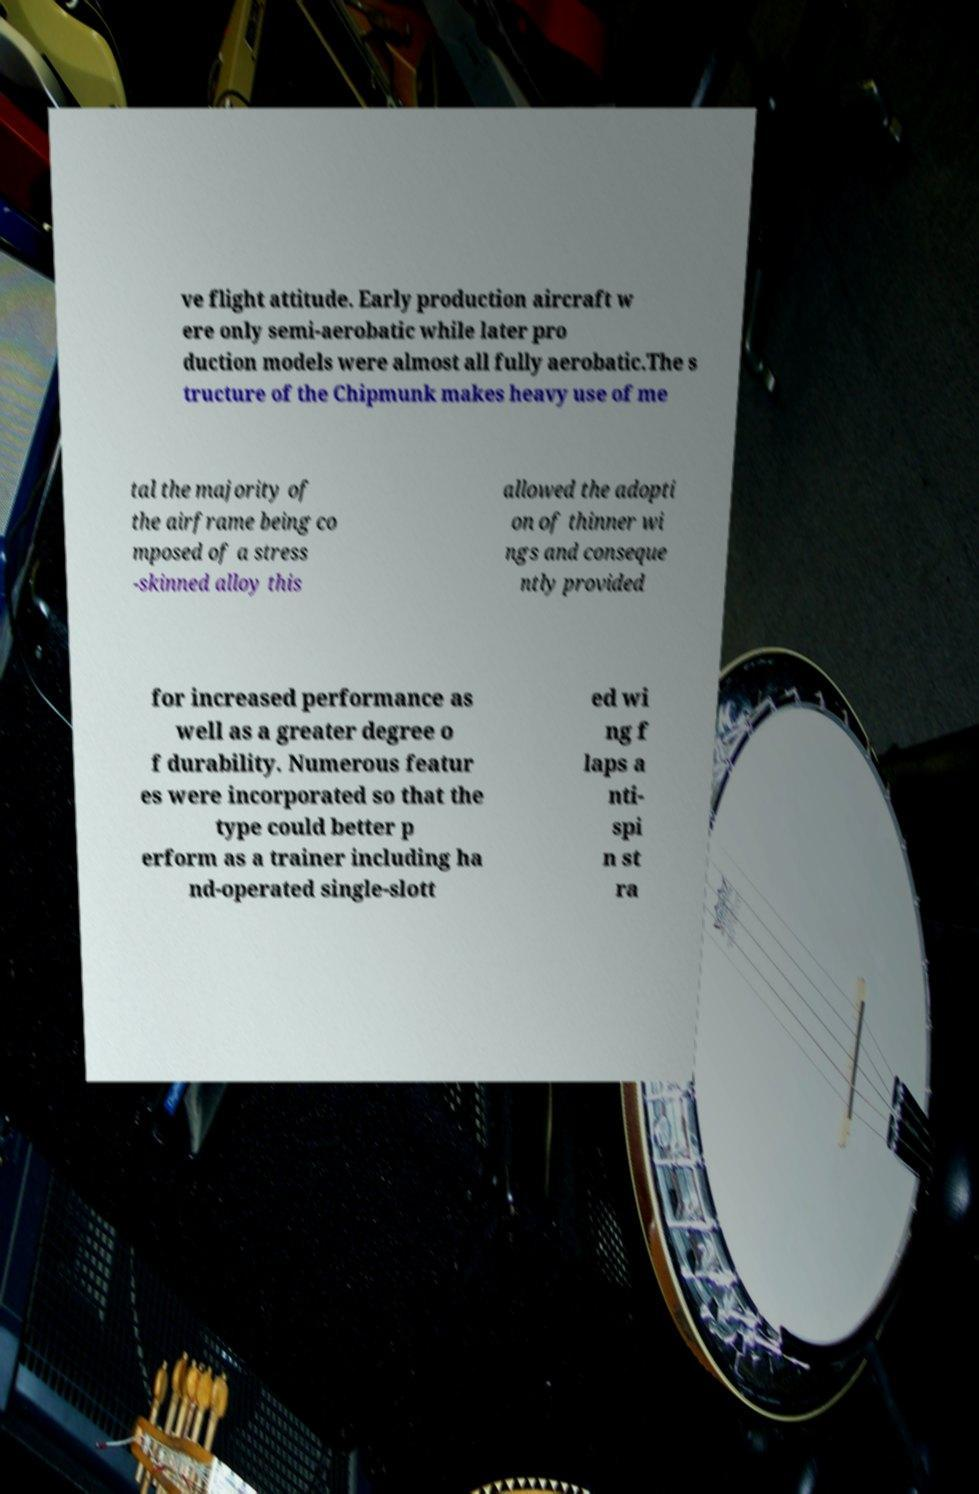Please identify and transcribe the text found in this image. ve flight attitude. Early production aircraft w ere only semi-aerobatic while later pro duction models were almost all fully aerobatic.The s tructure of the Chipmunk makes heavy use of me tal the majority of the airframe being co mposed of a stress -skinned alloy this allowed the adopti on of thinner wi ngs and conseque ntly provided for increased performance as well as a greater degree o f durability. Numerous featur es were incorporated so that the type could better p erform as a trainer including ha nd-operated single-slott ed wi ng f laps a nti- spi n st ra 